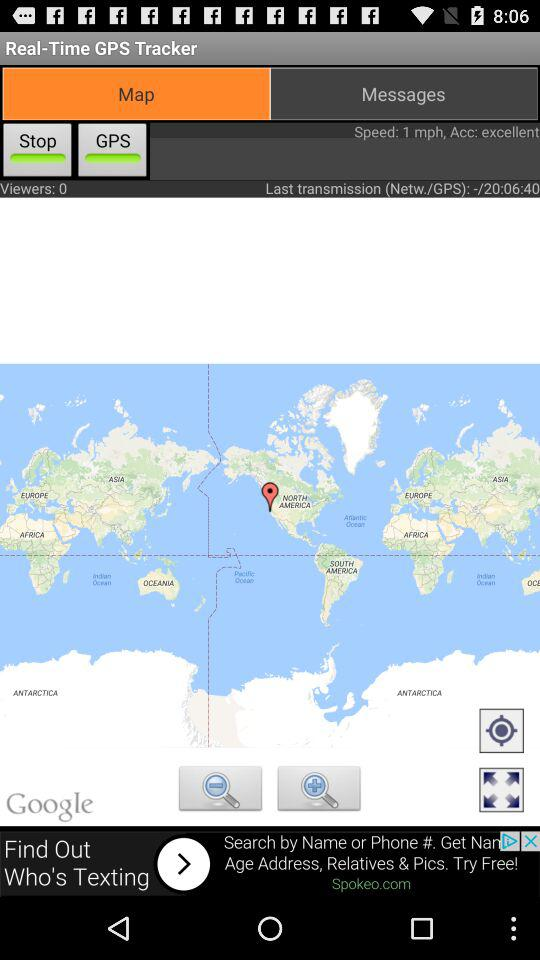What is the speed? The speed is 1 mph. 